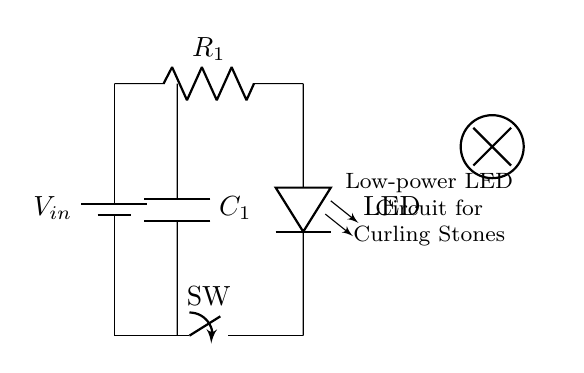What is the power source in this circuit? The circuit includes a component labeled as a battery, which serves as the power source. This is indicated by the battery symbol drawn at the top left of the diagram.
Answer: battery What is the function of the resistor in this circuit? The current limiting resistor is designated to manage the flow of current through the LED, preventing it from receiving too much current, which could lead to damage. This is shown in the diagram by the resistor symbol connected to the LED.
Answer: current limiting How many components are used in the circuit? The circuit features five components: a battery, resistor, LED, switch, and capacitor. These can be counted from their respective symbols in the diagram.
Answer: five What type of switch is used in this circuit? The switch indicated in the diagram is a standard mechanical switch, represented by a typical open/close symbol. It allows control over the circuit by creating or breaking a connection.
Answer: mechanical What is the role of the capacitor in this circuit? The capacitor is utilized for smoothing out voltage fluctuations, providing a stable voltage level to the LED. This is indicated in the diagram by its placement parallel to the power line leading to the LED.
Answer: smoothing voltage What is the purpose of using an LED in this circuit? An LED is used as a low-power light source for illumination. The diagram shows it as the main light-emitting component, which is powered when the switch is closed.
Answer: illumination What could happen if the current limiting resistor is not included? If the current limiting resistor is omitted, excessive current could flow through the LED, leading to its burning out or failure. This illustrates the importance of controlling current to ensure the longevity of the LED.
Answer: LED failure 